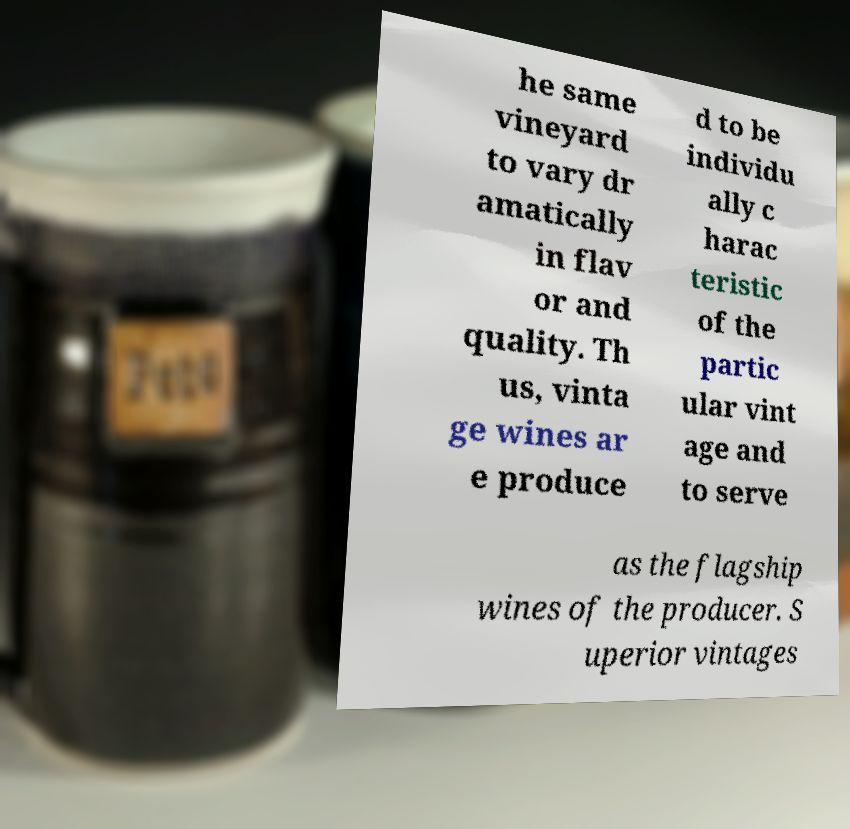Please read and relay the text visible in this image. What does it say? he same vineyard to vary dr amatically in flav or and quality. Th us, vinta ge wines ar e produce d to be individu ally c harac teristic of the partic ular vint age and to serve as the flagship wines of the producer. S uperior vintages 